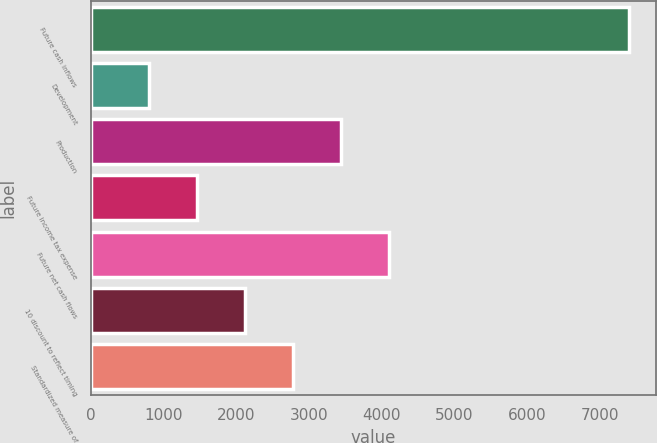Convert chart. <chart><loc_0><loc_0><loc_500><loc_500><bar_chart><fcel>Future cash inflows<fcel>Development<fcel>Production<fcel>Future income tax expense<fcel>Future net cash flows<fcel>10 discount to reflect timing<fcel>Standardized measure of<nl><fcel>7396<fcel>802<fcel>3439.6<fcel>1461.4<fcel>4099<fcel>2120.8<fcel>2780.2<nl></chart> 